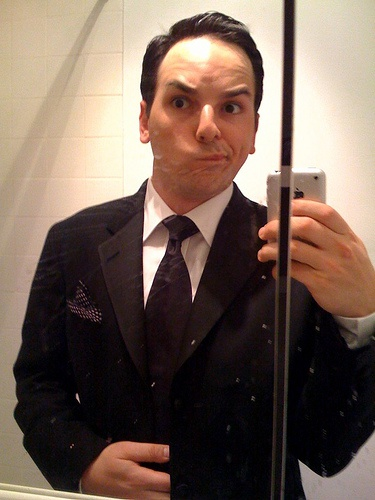Describe the objects in this image and their specific colors. I can see people in black, tan, brown, and maroon tones, tie in tan, black, gray, and brown tones, and cell phone in tan, gray, white, and darkgray tones in this image. 